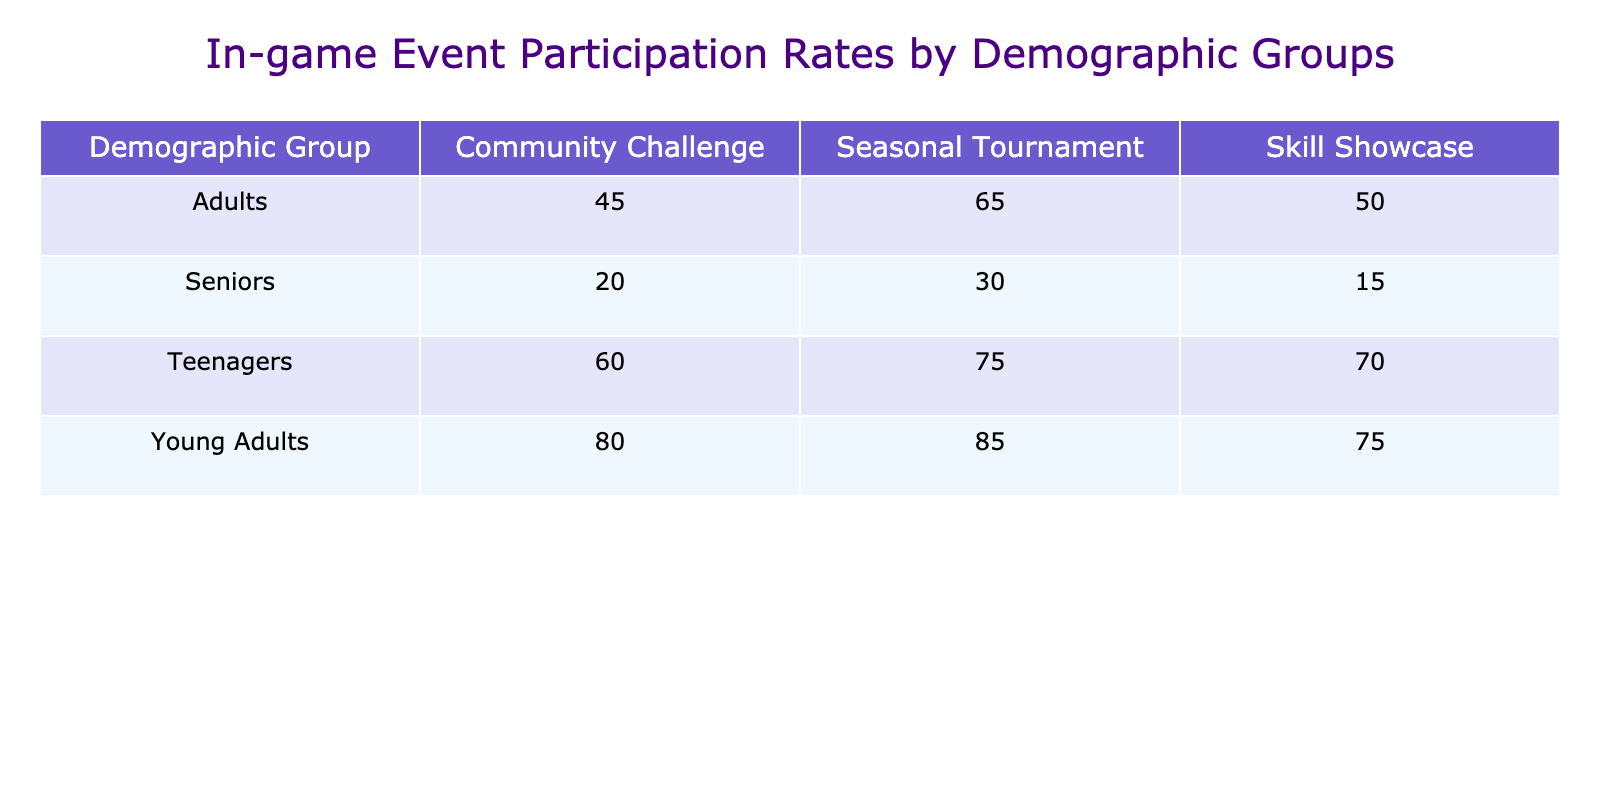What is the participation rate of teenagers in the Seasonal Tournament? The table shows that the participation rate for teenagers in the Seasonal Tournament is listed directly under the corresponding column. It states 75%.
Answer: 75% Which event type has the highest participation rate among young adults? Looking at the young adults' row, the event types listed are Seasonal Tournament (85%), Community Challenge (80%), and Skill Showcase (75%). The highest participation rate is 85% in the Seasonal Tournament.
Answer: 85% What is the average participation rate for seniors across all events? The participation rates for seniors are 30% for the Seasonal Tournament, 20% for the Community Challenge, and 15% for the Skill Showcase. To find the average: (30 + 20 + 15) / 3 = 65 / 3 = 21.67%.
Answer: 21.67% Is it true that adults have a higher participation rate in the Community Challenge than seniors? Checking the participation rates, adults have 45% in the Community Challenge, whereas seniors have only 20%. Therefore, it is true that adults have a higher rate.
Answer: Yes Which demographic group has the lowest participation rate in the Skill Showcase event? Looking at the Skill Showcase row, teenagers have 70%, young adults have 75%, adults have 50%, and seniors have 15%. The lowest participation rate is 15% by seniors.
Answer: Seniors What is the difference in participation rate between the Seasonal Tournament and the Skill Showcase for young adults? For young adults, the participation rate in the Seasonal Tournament is 85% and in the Skill Showcase is 75%. The difference is calculated as 85% - 75% = 10%.
Answer: 10% Do teenagers participate in the Community Challenge at a higher rate than adults? The table indicates that teenagers have a participation rate of 60% in the Community Challenge, and adults have a participation rate of 45%. Hence, teenagers participate at a higher rate.
Answer: Yes What is the total participation rate of adults across all events? The participation rates for adults are 65% for the Seasonal Tournament, 45% for the Community Challenge, and 50% for the Skill Showcase. To find the total: 65 + 45 + 50 = 160%.
Answer: 160% How does the overall participation of teenagers compare to that of seniors in the Seasonal Tournament? Teenagers have a participation rate of 75% in the Seasonal Tournament, while seniors have a participation rate of 30%. Thus, teenagers have a significantly higher participation rate compared to seniors.
Answer: Yes 